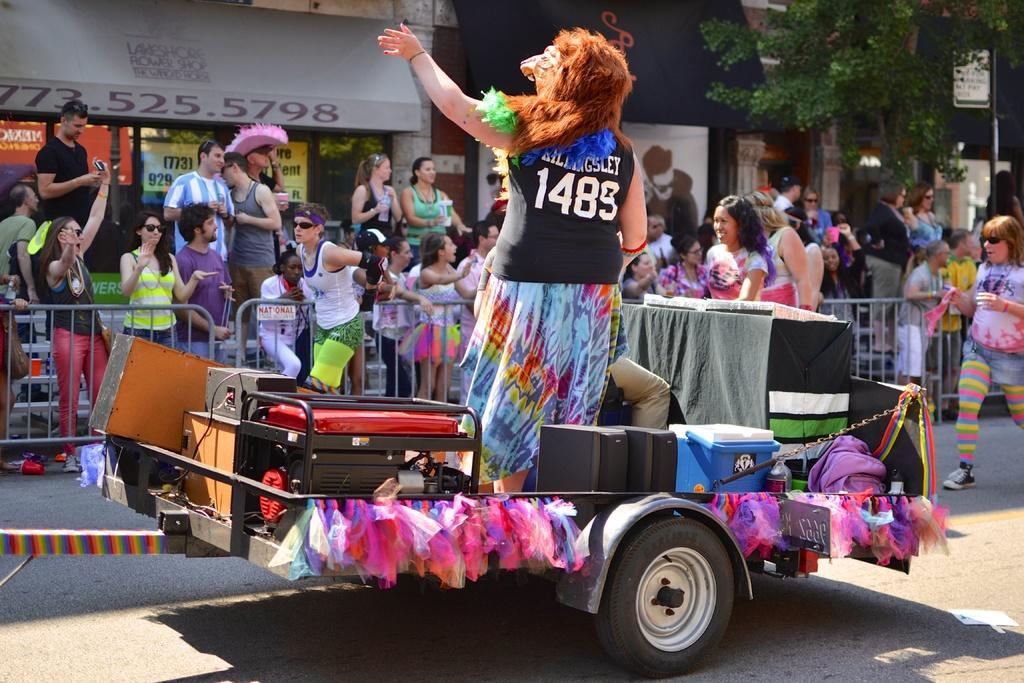How would you summarize this image in a sentence or two? In this image we can see a man and a woman in a vehicle which is on the road. In that the woman is standing wearing a mask. We can also see some containers and devices inside the vehicle. On the backside we can see a group of people standing beside a fence and some people sitting on a staircase. We can also see some buildings, a tree and a signboard with some text on it. 